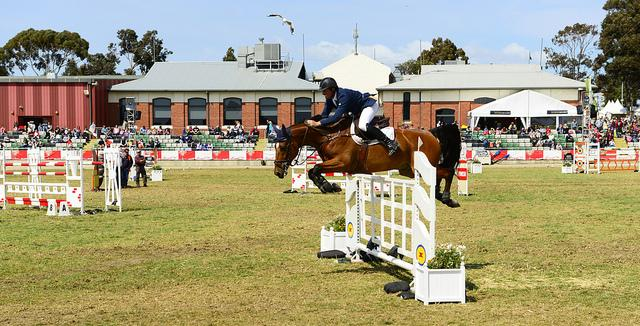What is the horse doing? jumping 